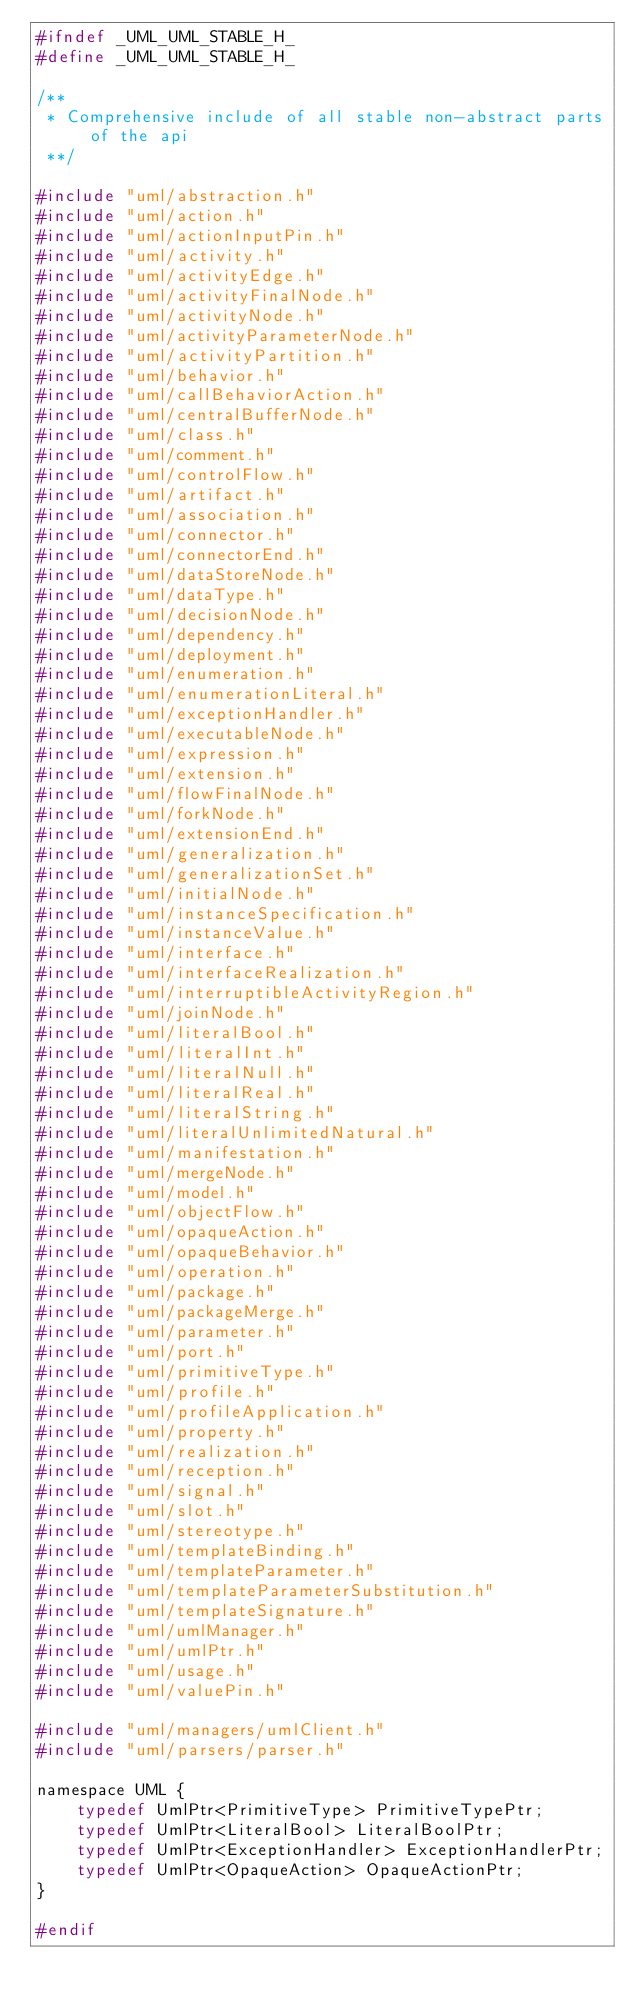Convert code to text. <code><loc_0><loc_0><loc_500><loc_500><_C_>#ifndef _UML_UML_STABLE_H_
#define _UML_UML_STABLE_H_

/**
 * Comprehensive include of all stable non-abstract parts of the api
 **/

#include "uml/abstraction.h"
#include "uml/action.h"
#include "uml/actionInputPin.h"
#include "uml/activity.h"
#include "uml/activityEdge.h"
#include "uml/activityFinalNode.h"
#include "uml/activityNode.h"
#include "uml/activityParameterNode.h"
#include "uml/activityPartition.h"
#include "uml/behavior.h"
#include "uml/callBehaviorAction.h"
#include "uml/centralBufferNode.h"
#include "uml/class.h"
#include "uml/comment.h"
#include "uml/controlFlow.h"
#include "uml/artifact.h"
#include "uml/association.h"
#include "uml/connector.h"
#include "uml/connectorEnd.h"
#include "uml/dataStoreNode.h"
#include "uml/dataType.h"
#include "uml/decisionNode.h"
#include "uml/dependency.h"
#include "uml/deployment.h"
#include "uml/enumeration.h"
#include "uml/enumerationLiteral.h"
#include "uml/exceptionHandler.h"
#include "uml/executableNode.h"
#include "uml/expression.h"
#include "uml/extension.h"
#include "uml/flowFinalNode.h"
#include "uml/forkNode.h"
#include "uml/extensionEnd.h"
#include "uml/generalization.h"
#include "uml/generalizationSet.h"
#include "uml/initialNode.h"
#include "uml/instanceSpecification.h"
#include "uml/instanceValue.h"
#include "uml/interface.h"
#include "uml/interfaceRealization.h"
#include "uml/interruptibleActivityRegion.h"
#include "uml/joinNode.h"
#include "uml/literalBool.h"
#include "uml/literalInt.h"
#include "uml/literalNull.h"
#include "uml/literalReal.h"
#include "uml/literalString.h"
#include "uml/literalUnlimitedNatural.h"
#include "uml/manifestation.h"
#include "uml/mergeNode.h"
#include "uml/model.h"
#include "uml/objectFlow.h"
#include "uml/opaqueAction.h"
#include "uml/opaqueBehavior.h"
#include "uml/operation.h"
#include "uml/package.h"
#include "uml/packageMerge.h"
#include "uml/parameter.h"
#include "uml/port.h"
#include "uml/primitiveType.h"
#include "uml/profile.h"
#include "uml/profileApplication.h"
#include "uml/property.h"
#include "uml/realization.h"
#include "uml/reception.h"
#include "uml/signal.h"
#include "uml/slot.h"
#include "uml/stereotype.h"
#include "uml/templateBinding.h"
#include "uml/templateParameter.h"
#include "uml/templateParameterSubstitution.h"
#include "uml/templateSignature.h"
#include "uml/umlManager.h"
#include "uml/umlPtr.h"
#include "uml/usage.h"
#include "uml/valuePin.h"

#include "uml/managers/umlClient.h"
#include "uml/parsers/parser.h"

namespace UML {
    typedef UmlPtr<PrimitiveType> PrimitiveTypePtr;
    typedef UmlPtr<LiteralBool> LiteralBoolPtr;
    typedef UmlPtr<ExceptionHandler> ExceptionHandlerPtr;
    typedef UmlPtr<OpaqueAction> OpaqueActionPtr;
}

#endif</code> 